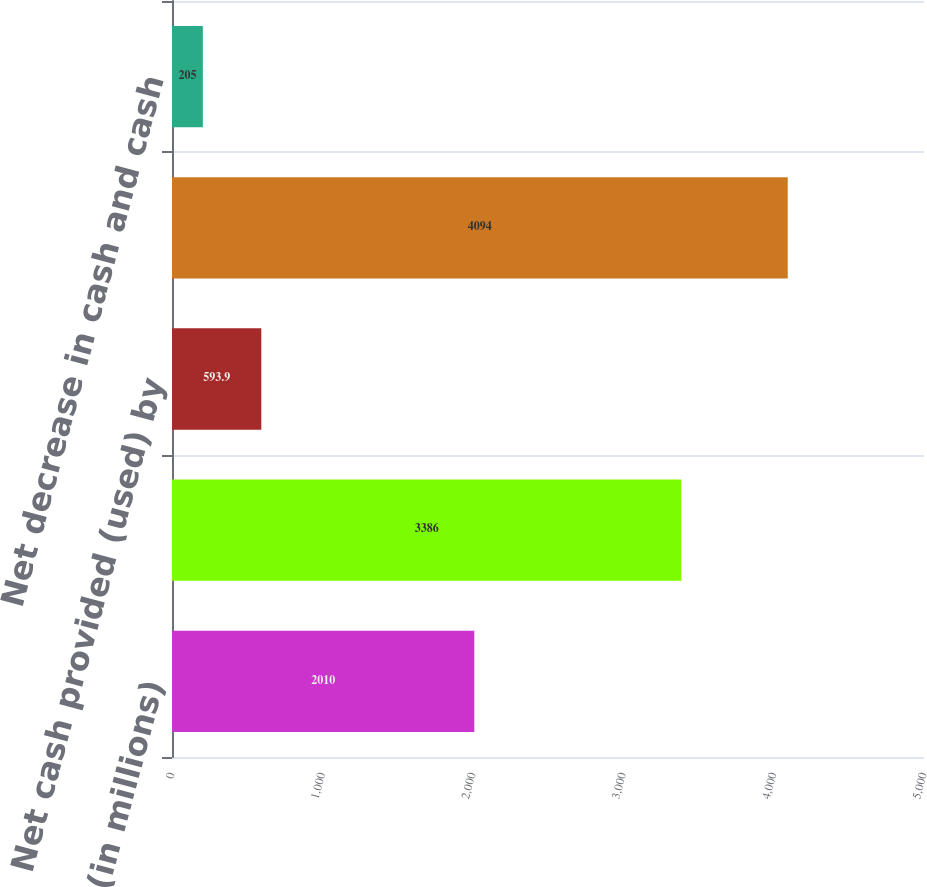Convert chart to OTSL. <chart><loc_0><loc_0><loc_500><loc_500><bar_chart><fcel>(in millions)<fcel>Net cash provided by operating<fcel>Net cash provided (used) by<fcel>Net cash used by investing<fcel>Net decrease in cash and cash<nl><fcel>2010<fcel>3386<fcel>593.9<fcel>4094<fcel>205<nl></chart> 